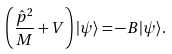<formula> <loc_0><loc_0><loc_500><loc_500>\left ( \frac { \hat { p } ^ { 2 } } { M } + V \right ) | \psi \rangle = - B | \psi \rangle .</formula> 